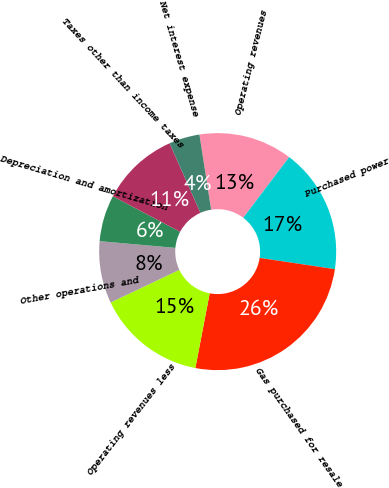Convert chart to OTSL. <chart><loc_0><loc_0><loc_500><loc_500><pie_chart><fcel>Operating revenues<fcel>Purchased power<fcel>Gas purchased for resale<fcel>Operating revenues less<fcel>Other operations and<fcel>Depreciation and amortization<fcel>Taxes other than income taxes<fcel>Net interest expense<nl><fcel>12.77%<fcel>17.06%<fcel>25.65%<fcel>14.92%<fcel>8.47%<fcel>6.33%<fcel>10.62%<fcel>4.18%<nl></chart> 